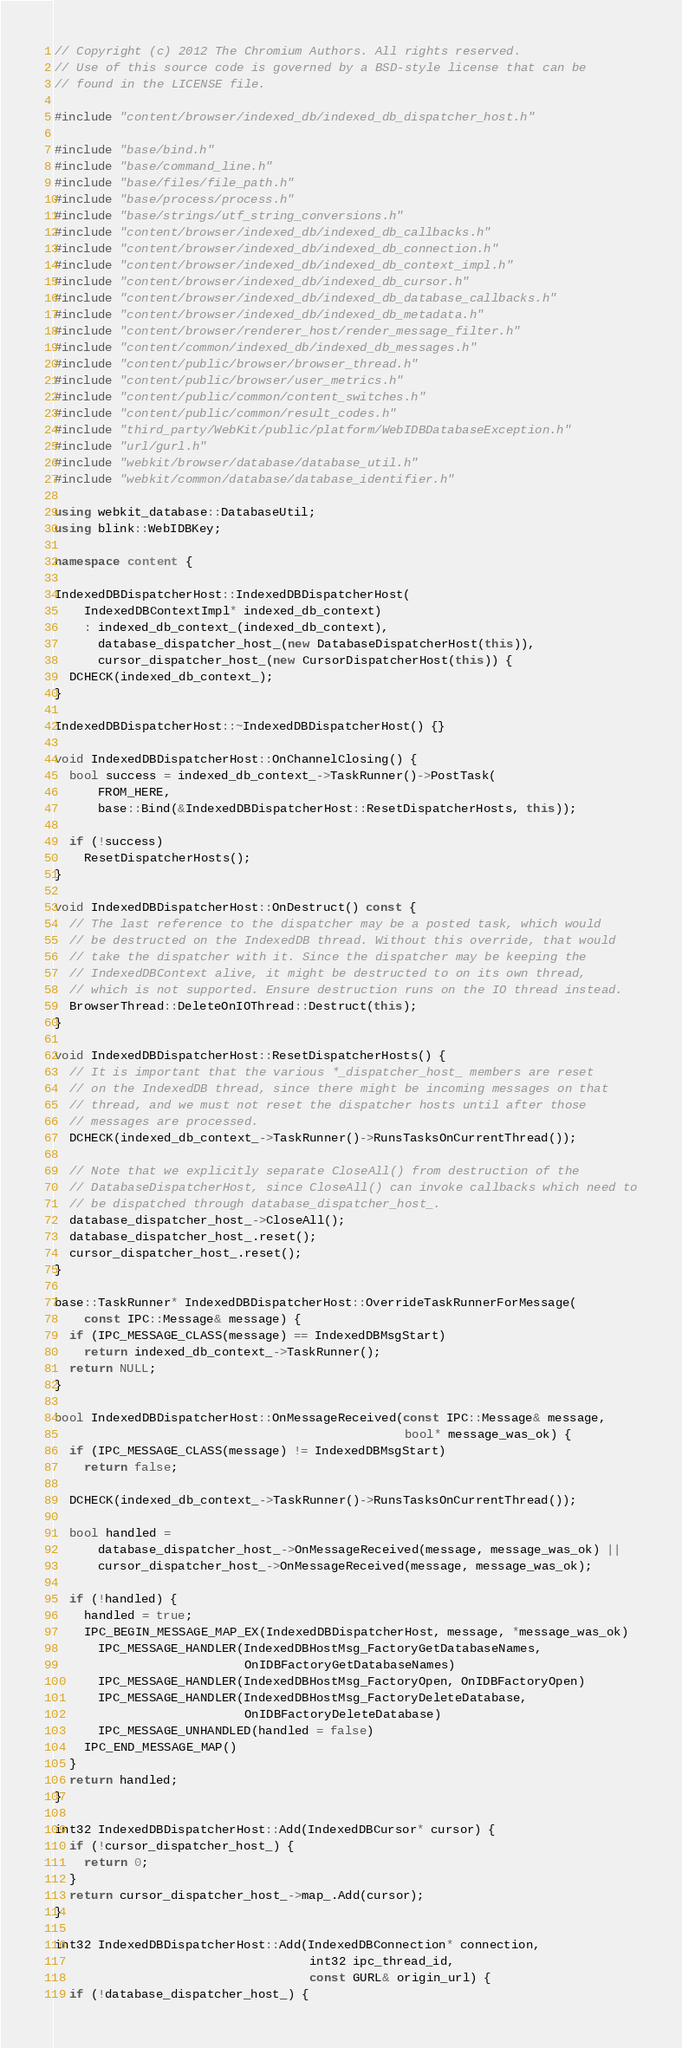Convert code to text. <code><loc_0><loc_0><loc_500><loc_500><_C++_>// Copyright (c) 2012 The Chromium Authors. All rights reserved.
// Use of this source code is governed by a BSD-style license that can be
// found in the LICENSE file.

#include "content/browser/indexed_db/indexed_db_dispatcher_host.h"

#include "base/bind.h"
#include "base/command_line.h"
#include "base/files/file_path.h"
#include "base/process/process.h"
#include "base/strings/utf_string_conversions.h"
#include "content/browser/indexed_db/indexed_db_callbacks.h"
#include "content/browser/indexed_db/indexed_db_connection.h"
#include "content/browser/indexed_db/indexed_db_context_impl.h"
#include "content/browser/indexed_db/indexed_db_cursor.h"
#include "content/browser/indexed_db/indexed_db_database_callbacks.h"
#include "content/browser/indexed_db/indexed_db_metadata.h"
#include "content/browser/renderer_host/render_message_filter.h"
#include "content/common/indexed_db/indexed_db_messages.h"
#include "content/public/browser/browser_thread.h"
#include "content/public/browser/user_metrics.h"
#include "content/public/common/content_switches.h"
#include "content/public/common/result_codes.h"
#include "third_party/WebKit/public/platform/WebIDBDatabaseException.h"
#include "url/gurl.h"
#include "webkit/browser/database/database_util.h"
#include "webkit/common/database/database_identifier.h"

using webkit_database::DatabaseUtil;
using blink::WebIDBKey;

namespace content {

IndexedDBDispatcherHost::IndexedDBDispatcherHost(
    IndexedDBContextImpl* indexed_db_context)
    : indexed_db_context_(indexed_db_context),
      database_dispatcher_host_(new DatabaseDispatcherHost(this)),
      cursor_dispatcher_host_(new CursorDispatcherHost(this)) {
  DCHECK(indexed_db_context_);
}

IndexedDBDispatcherHost::~IndexedDBDispatcherHost() {}

void IndexedDBDispatcherHost::OnChannelClosing() {
  bool success = indexed_db_context_->TaskRunner()->PostTask(
      FROM_HERE,
      base::Bind(&IndexedDBDispatcherHost::ResetDispatcherHosts, this));

  if (!success)
    ResetDispatcherHosts();
}

void IndexedDBDispatcherHost::OnDestruct() const {
  // The last reference to the dispatcher may be a posted task, which would
  // be destructed on the IndexedDB thread. Without this override, that would
  // take the dispatcher with it. Since the dispatcher may be keeping the
  // IndexedDBContext alive, it might be destructed to on its own thread,
  // which is not supported. Ensure destruction runs on the IO thread instead.
  BrowserThread::DeleteOnIOThread::Destruct(this);
}

void IndexedDBDispatcherHost::ResetDispatcherHosts() {
  // It is important that the various *_dispatcher_host_ members are reset
  // on the IndexedDB thread, since there might be incoming messages on that
  // thread, and we must not reset the dispatcher hosts until after those
  // messages are processed.
  DCHECK(indexed_db_context_->TaskRunner()->RunsTasksOnCurrentThread());

  // Note that we explicitly separate CloseAll() from destruction of the
  // DatabaseDispatcherHost, since CloseAll() can invoke callbacks which need to
  // be dispatched through database_dispatcher_host_.
  database_dispatcher_host_->CloseAll();
  database_dispatcher_host_.reset();
  cursor_dispatcher_host_.reset();
}

base::TaskRunner* IndexedDBDispatcherHost::OverrideTaskRunnerForMessage(
    const IPC::Message& message) {
  if (IPC_MESSAGE_CLASS(message) == IndexedDBMsgStart)
    return indexed_db_context_->TaskRunner();
  return NULL;
}

bool IndexedDBDispatcherHost::OnMessageReceived(const IPC::Message& message,
                                                bool* message_was_ok) {
  if (IPC_MESSAGE_CLASS(message) != IndexedDBMsgStart)
    return false;

  DCHECK(indexed_db_context_->TaskRunner()->RunsTasksOnCurrentThread());

  bool handled =
      database_dispatcher_host_->OnMessageReceived(message, message_was_ok) ||
      cursor_dispatcher_host_->OnMessageReceived(message, message_was_ok);

  if (!handled) {
    handled = true;
    IPC_BEGIN_MESSAGE_MAP_EX(IndexedDBDispatcherHost, message, *message_was_ok)
      IPC_MESSAGE_HANDLER(IndexedDBHostMsg_FactoryGetDatabaseNames,
                          OnIDBFactoryGetDatabaseNames)
      IPC_MESSAGE_HANDLER(IndexedDBHostMsg_FactoryOpen, OnIDBFactoryOpen)
      IPC_MESSAGE_HANDLER(IndexedDBHostMsg_FactoryDeleteDatabase,
                          OnIDBFactoryDeleteDatabase)
      IPC_MESSAGE_UNHANDLED(handled = false)
    IPC_END_MESSAGE_MAP()
  }
  return handled;
}

int32 IndexedDBDispatcherHost::Add(IndexedDBCursor* cursor) {
  if (!cursor_dispatcher_host_) {
    return 0;
  }
  return cursor_dispatcher_host_->map_.Add(cursor);
}

int32 IndexedDBDispatcherHost::Add(IndexedDBConnection* connection,
                                   int32 ipc_thread_id,
                                   const GURL& origin_url) {
  if (!database_dispatcher_host_) {</code> 